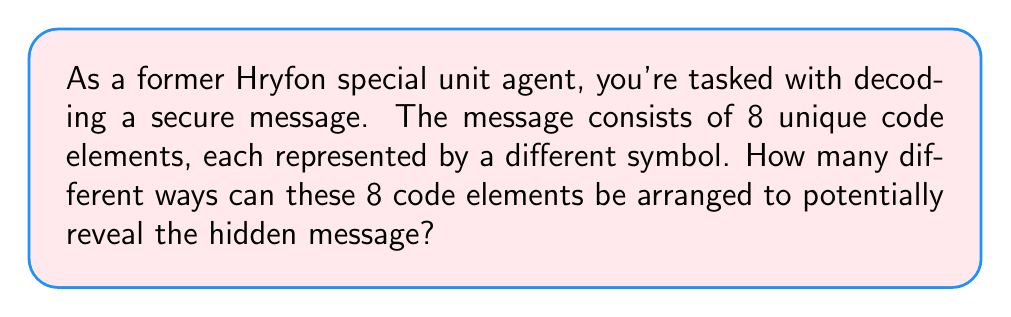Can you solve this math problem? To solve this problem, we need to use the concept of permutations from abstract algebra. A permutation is an arrangement of all the elements of a set in a specific order.

Given:
- We have 8 unique code elements
- Each element can be used only once in each arrangement

The number of permutations for n distinct objects is given by the factorial of n, denoted as n!

In this case, n = 8

Therefore, the number of permutations is:

$$8! = 8 \times 7 \times 6 \times 5 \times 4 \times 3 \times 2 \times 1$$

Let's calculate this step by step:

$$\begin{align}
8! &= 8 \times 7 \times 6 \times 5 \times 4 \times 3 \times 2 \times 1 \\
   &= 56 \times 6 \times 5 \times 4 \times 3 \times 2 \times 1 \\
   &= 336 \times 5 \times 4 \times 3 \times 2 \times 1 \\
   &= 1,680 \times 4 \times 3 \times 2 \times 1 \\
   &= 6,720 \times 3 \times 2 \times 1 \\
   &= 20,160 \times 2 \times 1 \\
   &= 40,320
\end{align}$$

This means there are 40,320 different ways to arrange the 8 code elements.
Answer: $40,320$ 